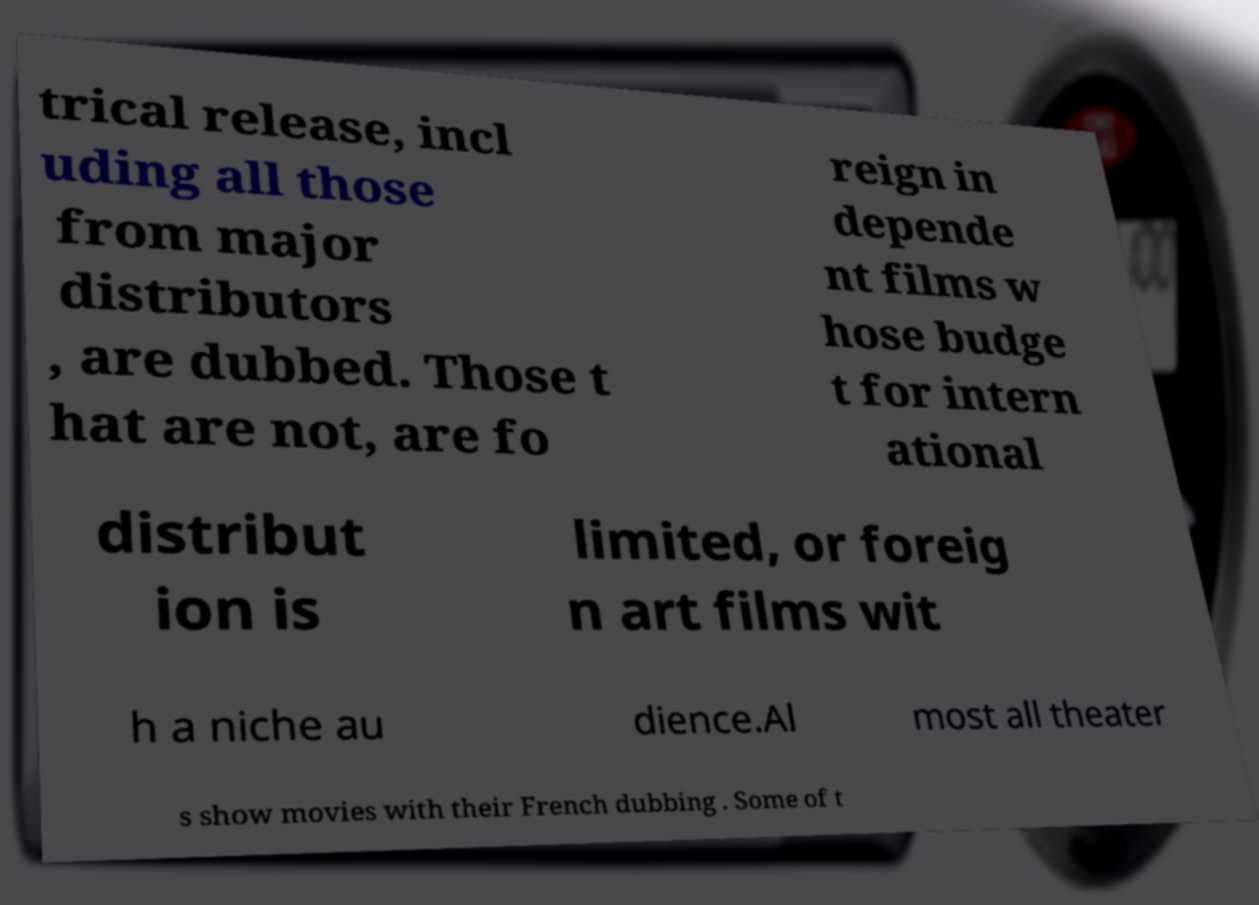I need the written content from this picture converted into text. Can you do that? trical release, incl uding all those from major distributors , are dubbed. Those t hat are not, are fo reign in depende nt films w hose budge t for intern ational distribut ion is limited, or foreig n art films wit h a niche au dience.Al most all theater s show movies with their French dubbing . Some of t 